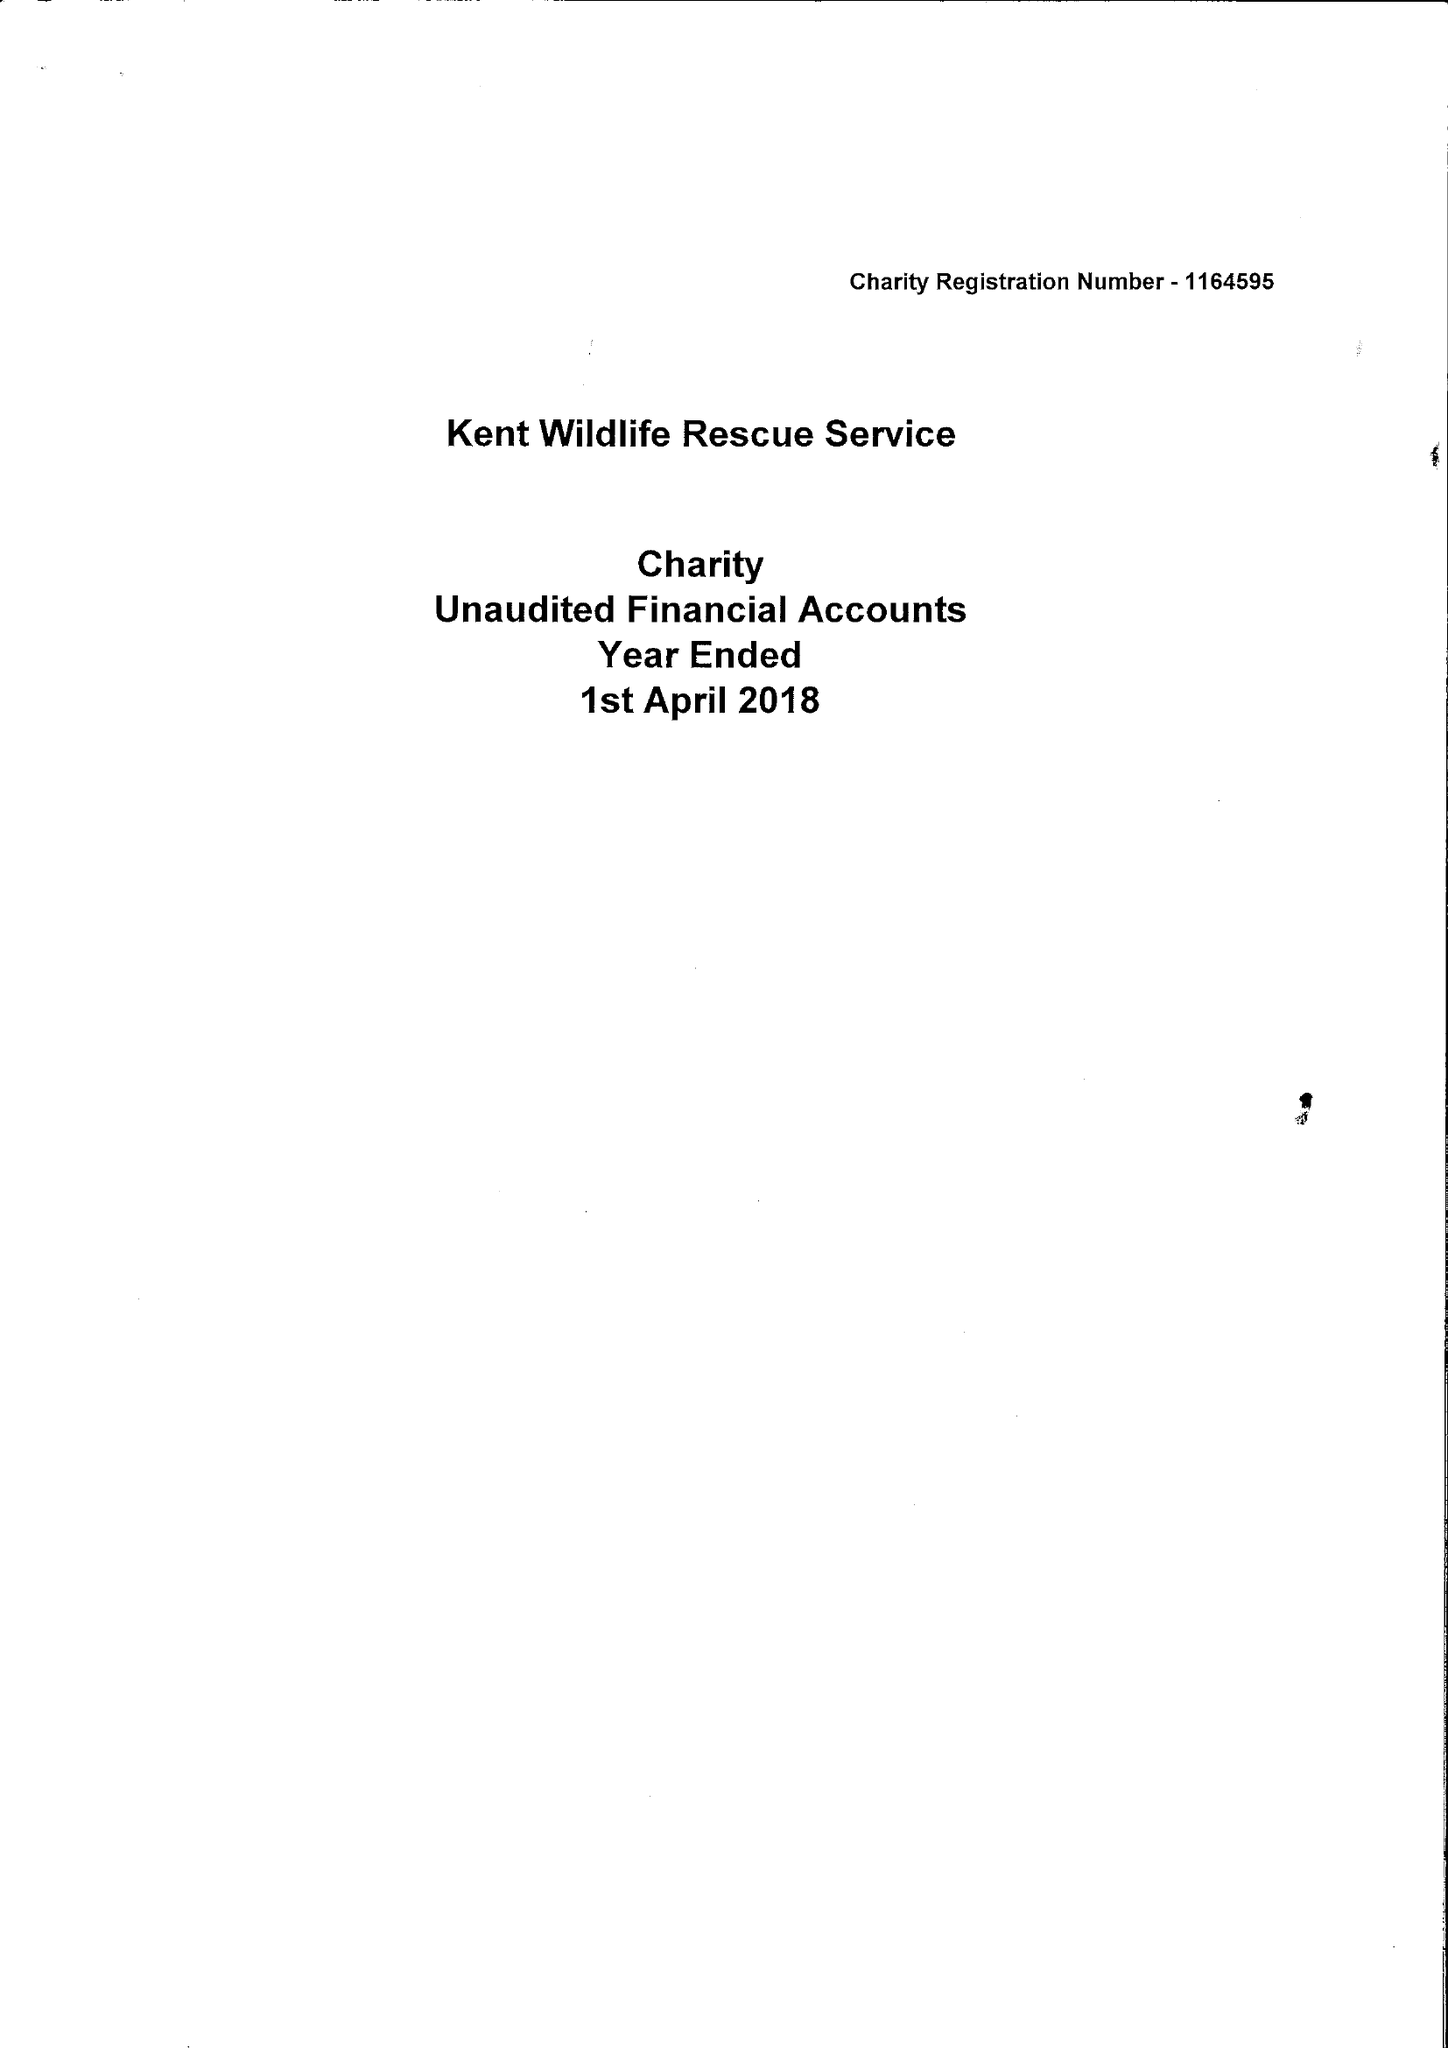What is the value for the report_date?
Answer the question using a single word or phrase. 2018-04-01 